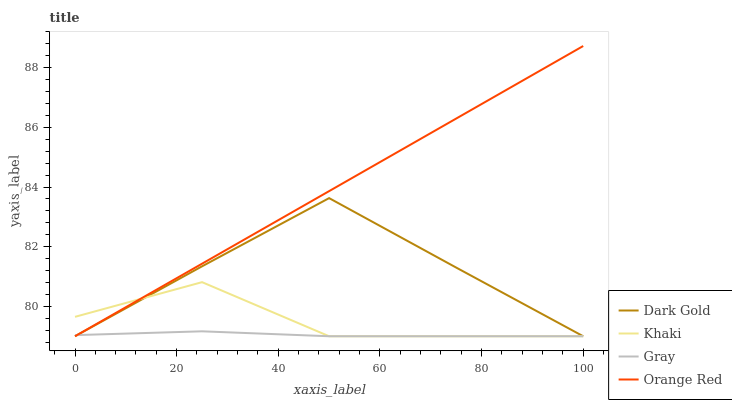Does Khaki have the minimum area under the curve?
Answer yes or no. No. Does Khaki have the maximum area under the curve?
Answer yes or no. No. Is Khaki the smoothest?
Answer yes or no. No. Is Orange Red the roughest?
Answer yes or no. No. Does Khaki have the highest value?
Answer yes or no. No. 